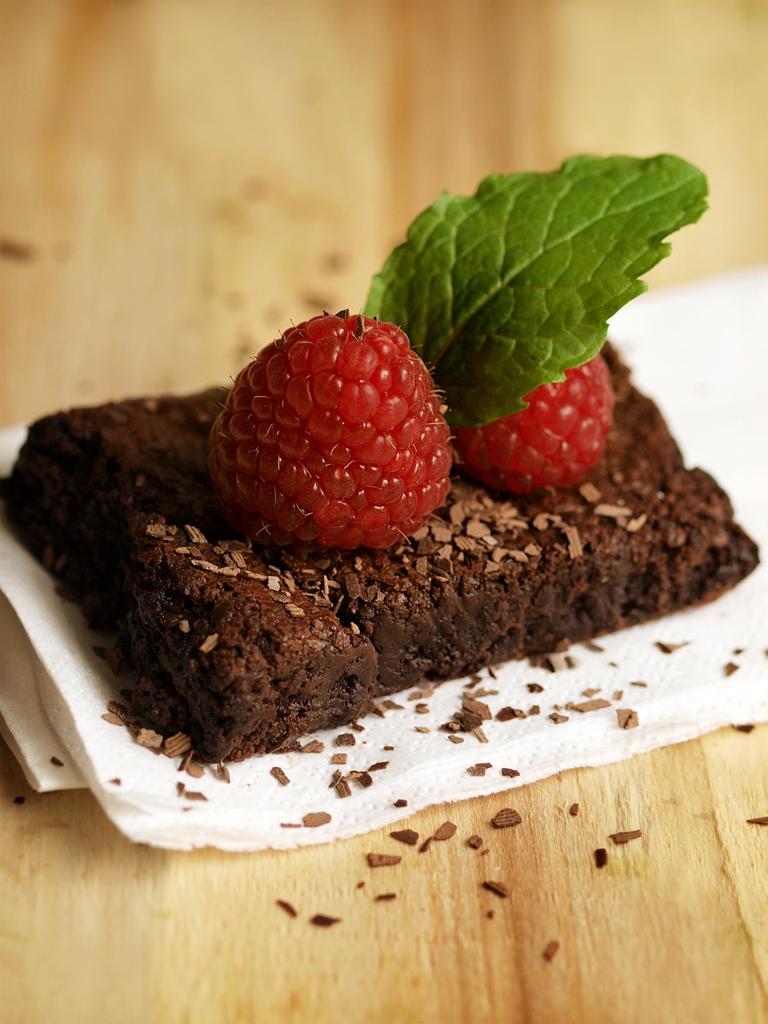In one or two sentences, can you explain what this image depicts? In this image there is a food item on a table. 